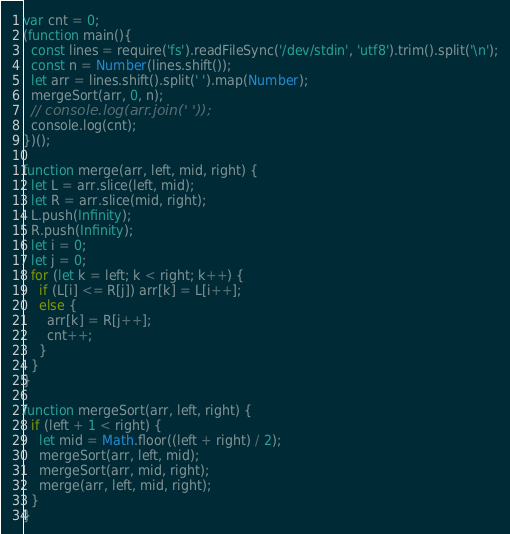Convert code to text. <code><loc_0><loc_0><loc_500><loc_500><_JavaScript_>var cnt = 0;
(function main(){
  const lines = require('fs').readFileSync('/dev/stdin', 'utf8').trim().split('\n');
  const n = Number(lines.shift());
  let arr = lines.shift().split(' ').map(Number);
  mergeSort(arr, 0, n);
  // console.log(arr.join(' '));
  console.log(cnt);
})();

function merge(arr, left, mid, right) {
  let L = arr.slice(left, mid);
  let R = arr.slice(mid, right);
  L.push(Infinity);
  R.push(Infinity);
  let i = 0;
  let j = 0;
  for (let k = left; k < right; k++) {
    if (L[i] <= R[j]) arr[k] = L[i++];
    else {
      arr[k] = R[j++];
      cnt++;
    }
  }
}

function mergeSort(arr, left, right) {
  if (left + 1 < right) {
    let mid = Math.floor((left + right) / 2);
    mergeSort(arr, left, mid);
    mergeSort(arr, mid, right);
    merge(arr, left, mid, right);
  }
}

</code> 